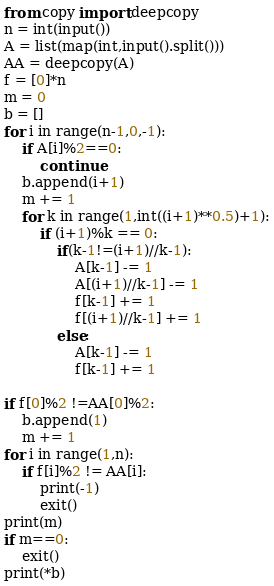<code> <loc_0><loc_0><loc_500><loc_500><_Python_>from copy import deepcopy
n = int(input())
A = list(map(int,input().split()))
AA = deepcopy(A)
f = [0]*n
m = 0
b = []
for i in range(n-1,0,-1):
    if A[i]%2==0:
        continue
    b.append(i+1)
    m += 1
    for k in range(1,int((i+1)**0.5)+1):
        if (i+1)%k == 0:
            if(k-1!=(i+1)//k-1):
                A[k-1] -= 1
                A[(i+1)//k-1] -= 1
                f[k-1] += 1
                f[(i+1)//k-1] += 1
            else:
                A[k-1] -= 1
                f[k-1] += 1

if f[0]%2 !=AA[0]%2:
    b.append(1)
    m += 1
for i in range(1,n):
    if f[i]%2 != AA[i]:
        print(-1)
        exit()
print(m)
if m==0:
    exit()
print(*b)</code> 